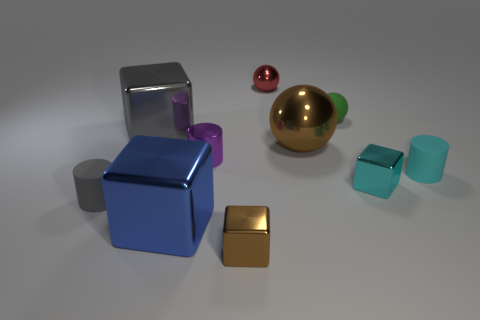Subtract 1 blocks. How many blocks are left? 3 Subtract all blocks. How many objects are left? 6 Add 2 small blue shiny blocks. How many small blue shiny blocks exist? 2 Subtract 0 brown cylinders. How many objects are left? 10 Subtract all matte cylinders. Subtract all gray shiny objects. How many objects are left? 7 Add 9 blue objects. How many blue objects are left? 10 